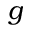<formula> <loc_0><loc_0><loc_500><loc_500>g</formula> 